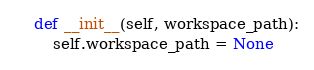<code> <loc_0><loc_0><loc_500><loc_500><_Python_>    def __init__(self, workspace_path):
        self.workspace_path = None
</code> 